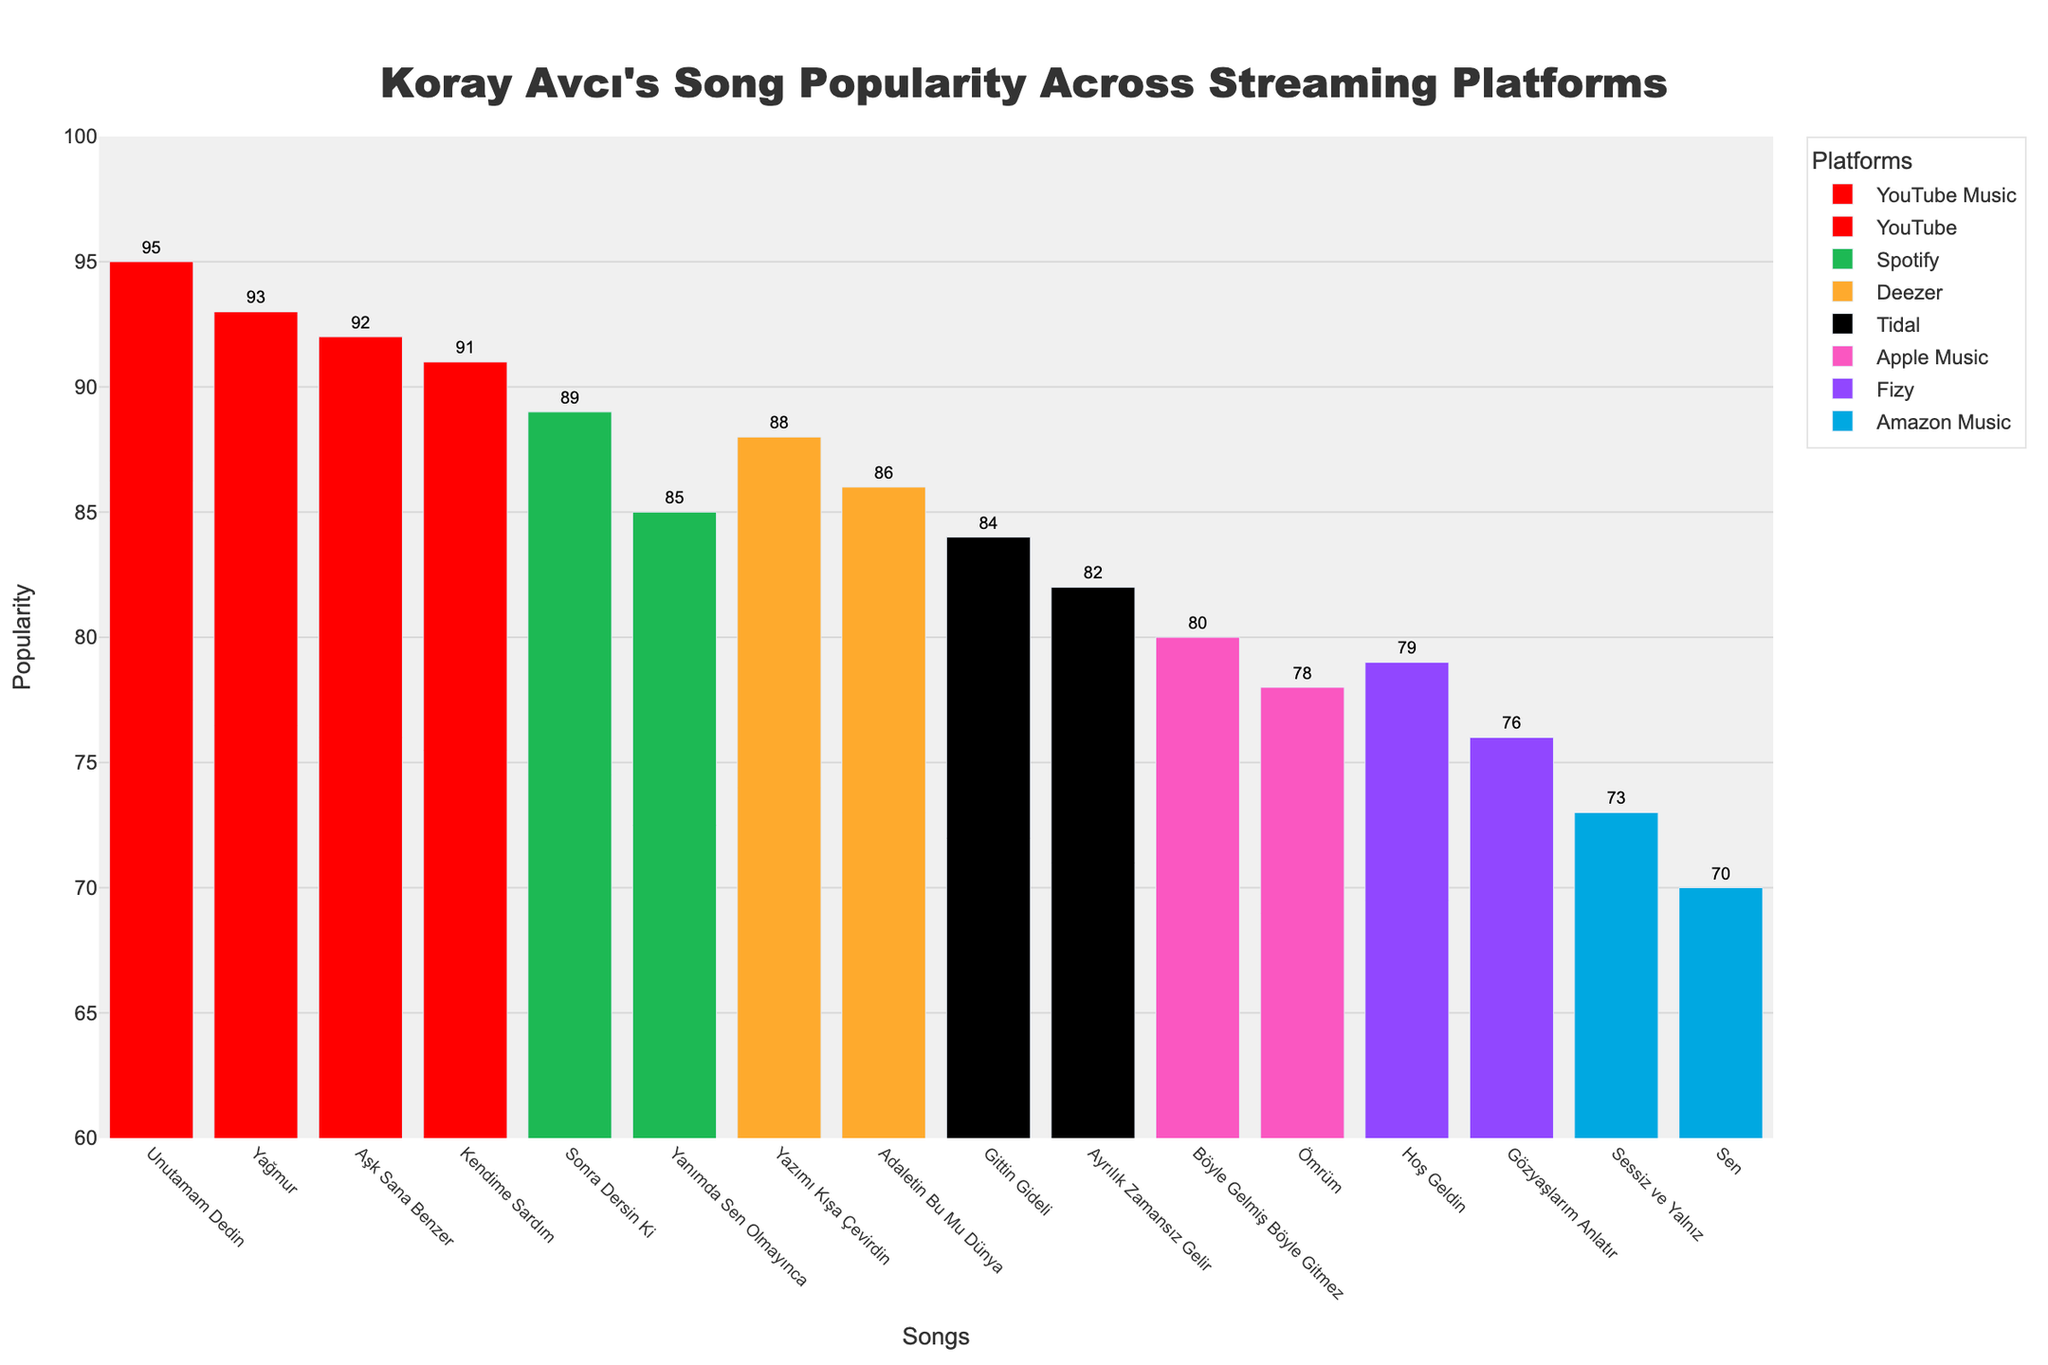Which streaming platform shows the highest popularity score for Koray Avcı's songs? Based on the Manhattan Plot, "Unutamam Dedin" on YouTube Music has the highest popularity score of 95.
Answer: YouTube Music Which song has the lowest popularity score, and on which platform is it? The song "Sen" on Amazon Music has the lowest popularity score of 70.
Answer: Sen on Amazon Music What is the average popularity score of Koray Avcı’s songs on Spotify? The average of the popularity scores for the songs on Spotify ("Adaletin Bu Mu Dünya" – 85 and "Sonra Dersin Ki" – 89) is (85 + 89) / 2 = 87.
Answer: 87 Compare the popularity scores of "Aşk Sana Benzer" on YouTube and "Yanımda Sen Olmayınca" on Deezer. Which song is more popular? "Aşk Sana Benzer" on YouTube has a popularity score of 92, while "Yanımda Sen Olmayınca" on Deezer has a popularity score of 88. Thus, "Aşk Sana Benzer" is more popular.
Answer: Aşk Sana Benzer List the platforms with at least one song having a popularity score of 90 or more. The platforms with songs having a popularity score of 90 or more are YouTube ("Aşk Sana Benzer" – 92, "Kendime Sardım" – 91), YouTube Music ("Unutamam Dedin" – 95, "Yağmur" – 93), and Spotify ("Sonra Dersin Ki" – 89).
Answer: YouTube, YouTube Music, Spotify Determine the difference in popularity score between "Gittin Gideli" on Tidal and "Ömrüm" on Fizy. The popularity score for "Gittin Gideli" on Tidal is 84, and for "Ömrüm" on Fizy is 79. The difference is 84 - 79 = 5.
Answer: 5 Which song on Apple Music has the highest popularity score? The song "Böyle Gelmiş Böyle Gitmez" on Apple Music has the highest popularity score of 80.
Answer: Böyle Gelmiş Böyle Gitmez What is the combined popularity score of all songs listed on Deezer? The songs on Deezer are "Yanımda Sen Olmayınca" with a popularity score of 88 and "Yazımı Kışa Çevirdin" with a popularity score of 86. The combined score is 88 + 86 = 174.
Answer: 174 Across all streaming platforms, how many songs have a popularity score greater than or equal to 85? Looking at the plot, the songs "Adaletin Bu Mu Dünya" (Spotify – 85), "Aşk Sana Benzer" (YouTube – 92), "Yanımda Sen Olmayınca" (Deezer – 88), "Sonra Dersin Ki" (Spotify – 89), "Gittin Gideli" (Tidal – 84), "Unutamam Dedin" (YouTube Music – 95), "Kendime Sardım" (YouTube – 91), "Yağmur" (YouTube Music – 93), and "Yazımı Kışa Çevirdin" (Deezer – 86) meet this criterion, for a total of 9 songs.
Answer: 9 